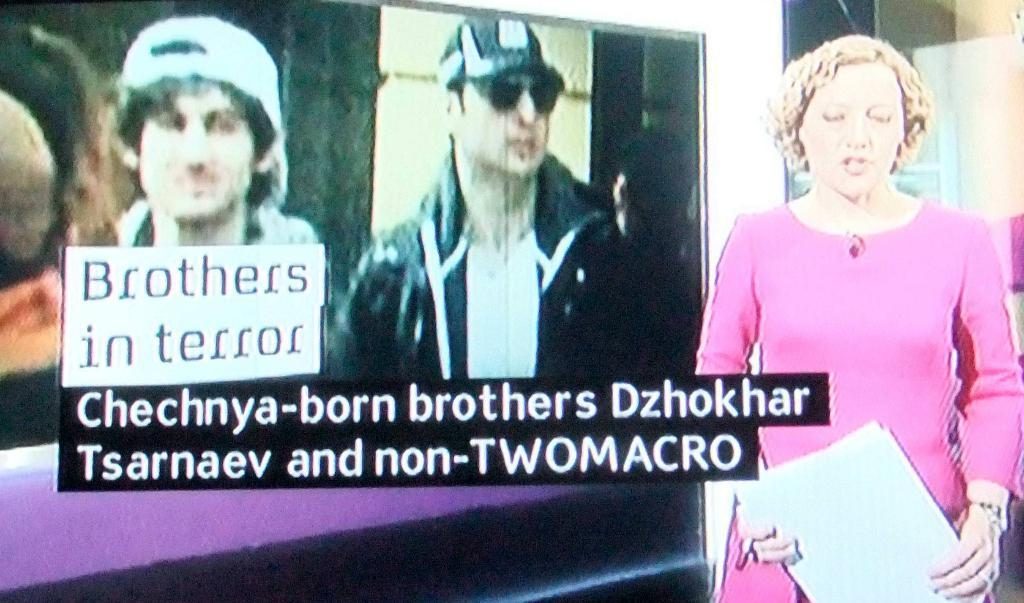What is the primary subject of the image? There is a woman in the image. What is the woman doing in the image? The woman is standing and holding papers. What can be seen on a separate surface in the image? There is a screen visible in the image, and a person is visible on the screen. What additional information is displayed on the screen? Some text is visible on the screen. Can you describe the roof of the building in the image? There is no roof visible in the image; it only shows a woman standing and holding papers, a screen with a person and text, and no other structures. 